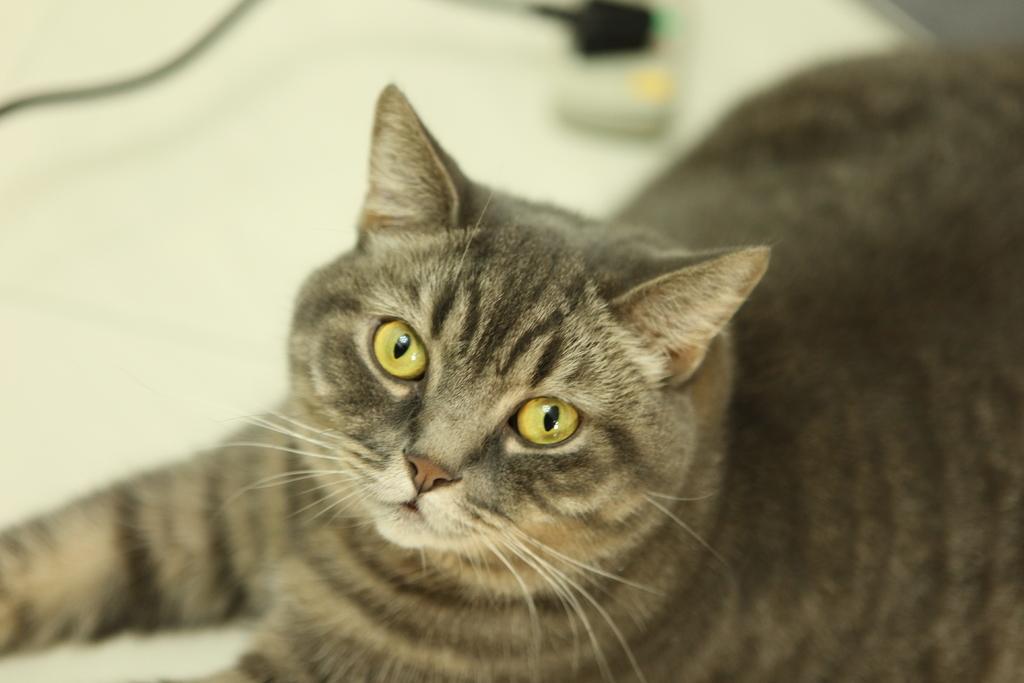Please provide a concise description of this image. In this picture I can see a cat, and there is blur background. 